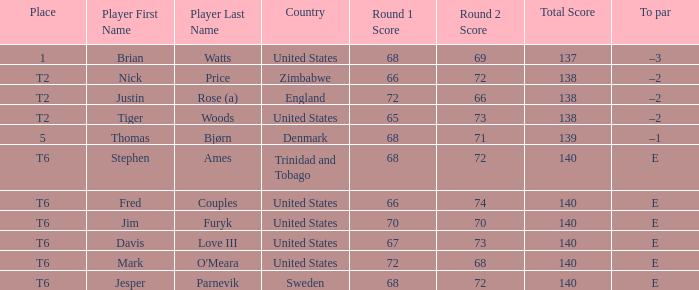In which location was the american tiger woods situated? T2. 